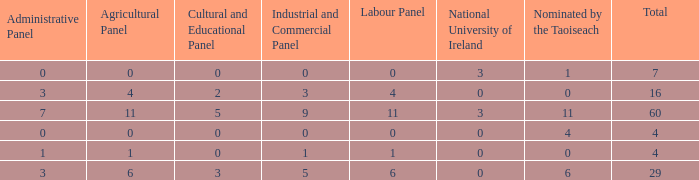What is the average agricultural panel of the composition with a labour panel less than 6, more than 0 nominations by Taoiseach, and a total less than 4? None. 